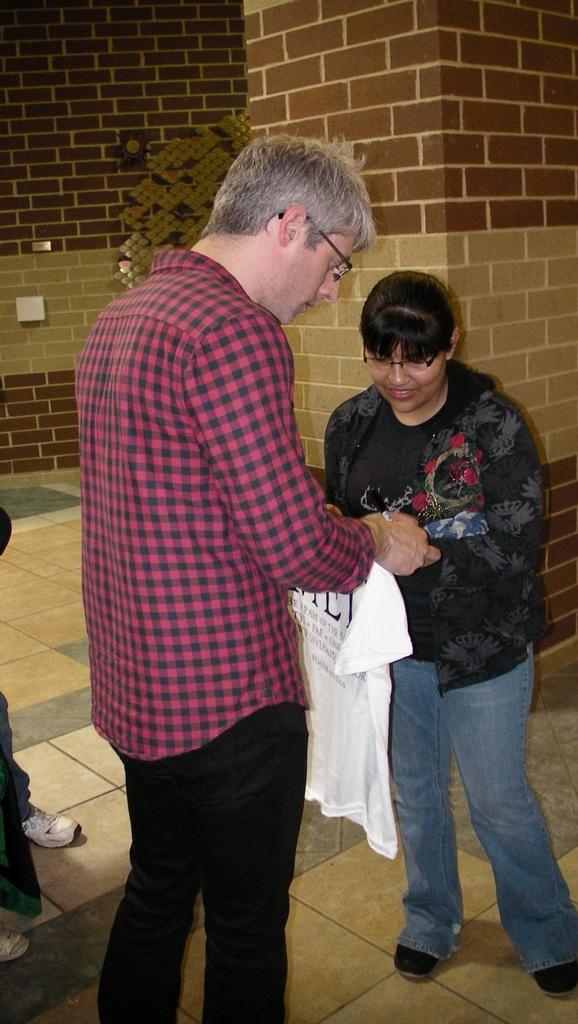What is the main subject of the image? There is a man standing in the center of the image. What is the man holding in the image? The man is holding a shirt. Can you describe the woman next to the man? There is a lady next to the man. What can be seen in the background of the image? There is a wall in the background of the image. What type of toad can be seen performing arithmetic in the image? There is no toad or arithmetic activity present in the image. Is there a tent visible in the image? No, there is no tent present in the image. 